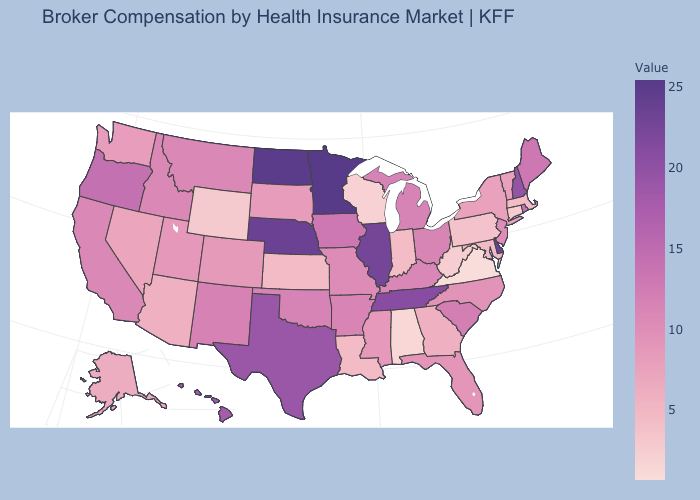Among the states that border Delaware , does Pennsylvania have the lowest value?
Quick response, please. Yes. Does Virginia have the lowest value in the South?
Quick response, please. Yes. Among the states that border Illinois , does Iowa have the highest value?
Quick response, please. Yes. Among the states that border Iowa , does Minnesota have the highest value?
Quick response, please. Yes. Does Wyoming have the lowest value in the West?
Write a very short answer. Yes. Does North Dakota have a lower value than New Mexico?
Concise answer only. No. 